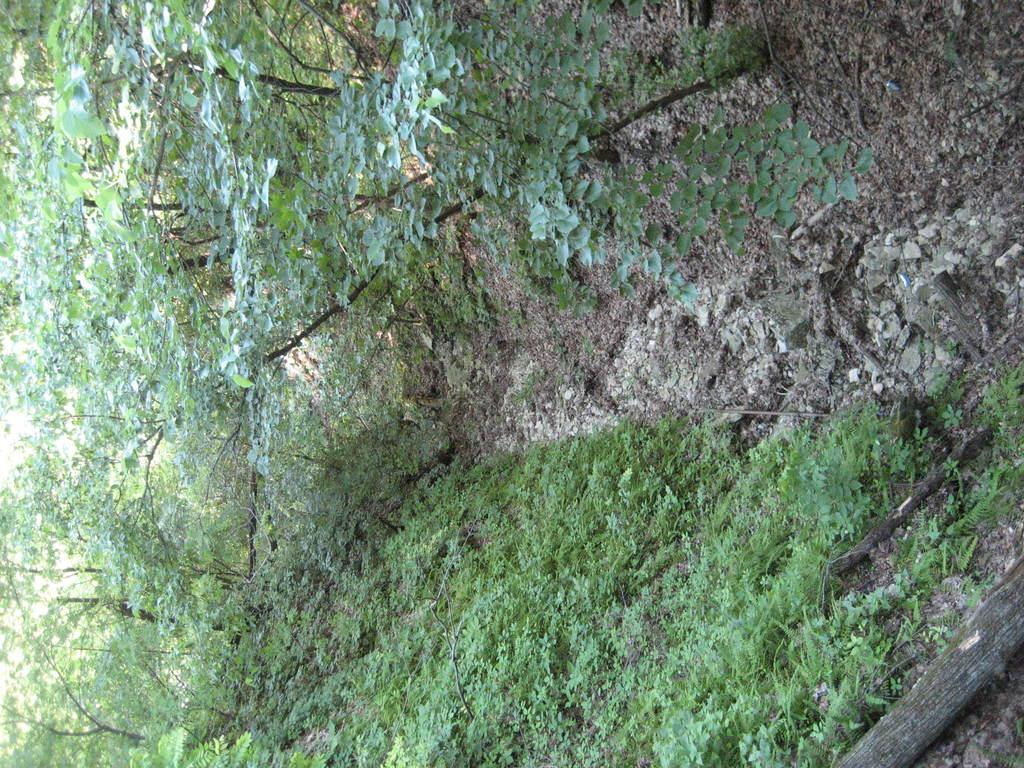What type of vegetation can be seen in the image? There are plants and trees in the image. Can you describe the wooden object on the ground? There is a wooden log on the ground in the image. What type of cream is being offered by the son in the image? There is no son or cream present in the image. 